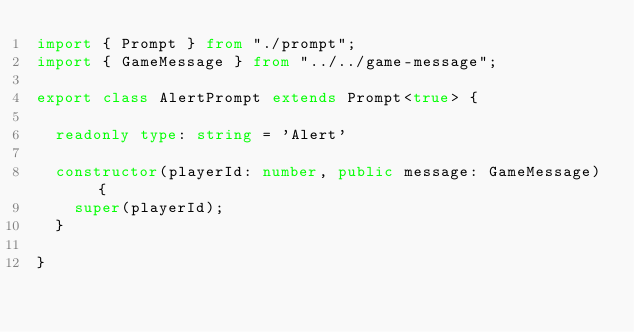Convert code to text. <code><loc_0><loc_0><loc_500><loc_500><_TypeScript_>import { Prompt } from "./prompt";
import { GameMessage } from "../../game-message";

export class AlertPrompt extends Prompt<true> {

  readonly type: string = 'Alert'

  constructor(playerId: number, public message: GameMessage) {
    super(playerId);
  }

}
</code> 